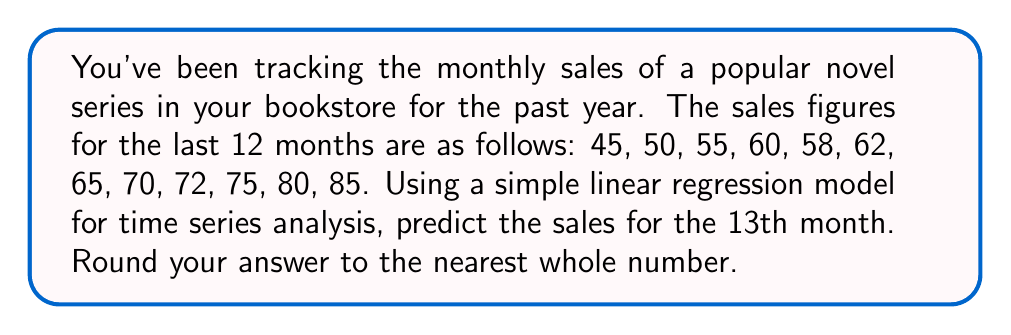Teach me how to tackle this problem. To predict the sales for the 13th month using a simple linear regression model, we'll follow these steps:

1. Assign time values (t) to each month, starting from 1 to 12.

2. Calculate the means of t and y (sales):
   $\bar{t} = \frac{1+2+...+12}{12} = \frac{78}{12} = 6.5$
   $\bar{y} = \frac{45+50+...+85}{12} = \frac{777}{12} = 64.75$

3. Calculate the slope (b) of the regression line:
   $b = \frac{\sum(t_i - \bar{t})(y_i - \bar{y})}{\sum(t_i - \bar{t})^2}$

   Numerator: $(1-6.5)(45-64.75) + (2-6.5)(50-64.75) + ... + (12-6.5)(85-64.75) = 1155$
   Denominator: $(1-6.5)^2 + (2-6.5)^2 + ... + (12-6.5)^2 = 143$

   $b = \frac{1155}{143} = 8.0769$

4. Calculate the y-intercept (a):
   $a = \bar{y} - b\bar{t} = 64.75 - 8.0769 * 6.5 = 12.25$

5. The linear regression equation is:
   $y = a + bt = 12.25 + 8.0769t$

6. Predict the sales for the 13th month by plugging in t = 13:
   $y = 12.25 + 8.0769 * 13 = 117.25$

7. Rounding to the nearest whole number: 117
Answer: 117 books 